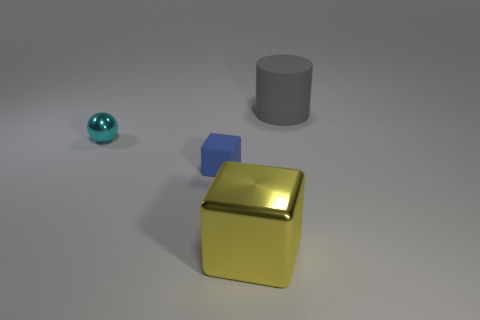There is a thing that is both on the left side of the big block and on the right side of the ball; what size is it? The object that is situated to the left of the big yellow block and to the right of the small blue ball appears to be a medium-sized gray cylinder. 